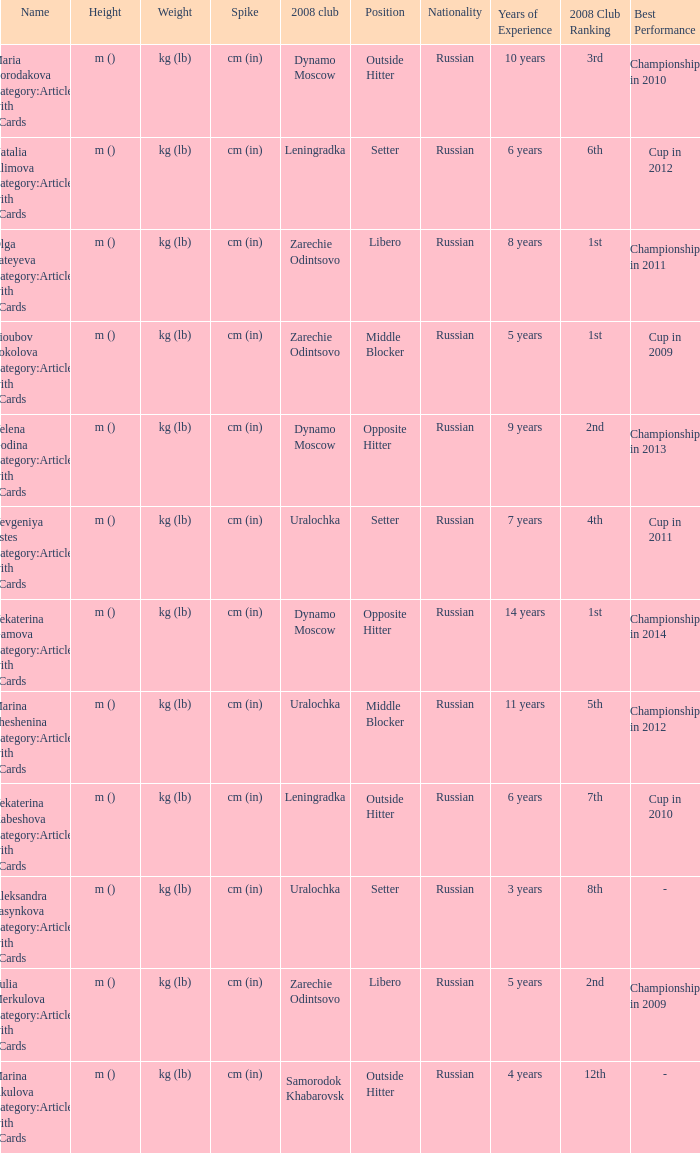What is the name when the 2008 club is zarechie odintsovo? Olga Fateyeva Category:Articles with hCards, Lioubov Sokolova Category:Articles with hCards, Yulia Merkulova Category:Articles with hCards. 